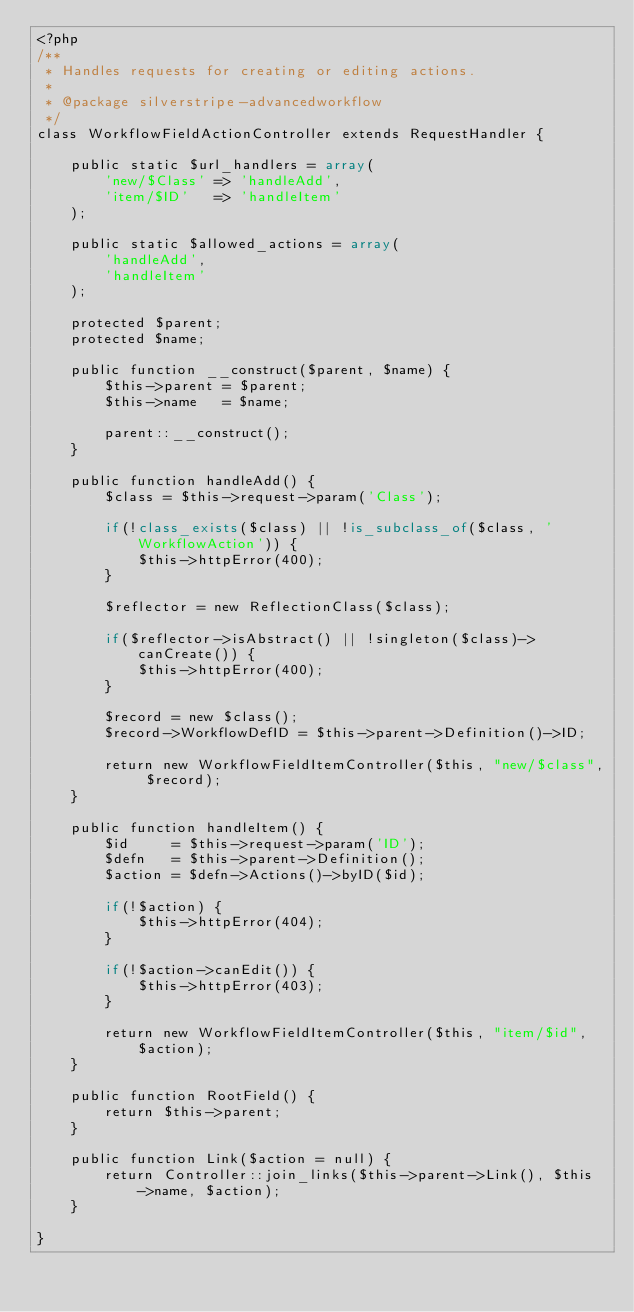<code> <loc_0><loc_0><loc_500><loc_500><_PHP_><?php
/**
 * Handles requests for creating or editing actions.
 *
 * @package silverstripe-advancedworkflow
 */
class WorkflowFieldActionController extends RequestHandler {

	public static $url_handlers = array(
		'new/$Class' => 'handleAdd',
		'item/$ID'   => 'handleItem'
	);

	public static $allowed_actions = array(
		'handleAdd',
		'handleItem'
	);

	protected $parent;
	protected $name;

	public function __construct($parent, $name) {
		$this->parent = $parent;
		$this->name   = $name;

		parent::__construct();
	}

	public function handleAdd() {
		$class = $this->request->param('Class');

		if(!class_exists($class) || !is_subclass_of($class, 'WorkflowAction')) {
			$this->httpError(400);
		}

		$reflector = new ReflectionClass($class);

		if($reflector->isAbstract() || !singleton($class)->canCreate()) {
			$this->httpError(400);
		}

		$record = new $class();
		$record->WorkflowDefID = $this->parent->Definition()->ID;

		return new WorkflowFieldItemController($this, "new/$class", $record);
	}

	public function handleItem() {
		$id     = $this->request->param('ID');
		$defn   = $this->parent->Definition();
		$action = $defn->Actions()->byID($id);

		if(!$action) {
			$this->httpError(404);
		}

		if(!$action->canEdit()) {
			$this->httpError(403);
		}

		return new WorkflowFieldItemController($this, "item/$id", $action);
	}

	public function RootField() {
		return $this->parent;
	}

	public function Link($action = null) {
		return Controller::join_links($this->parent->Link(), $this->name, $action);
	}

}</code> 